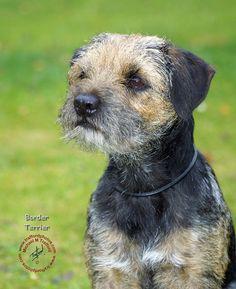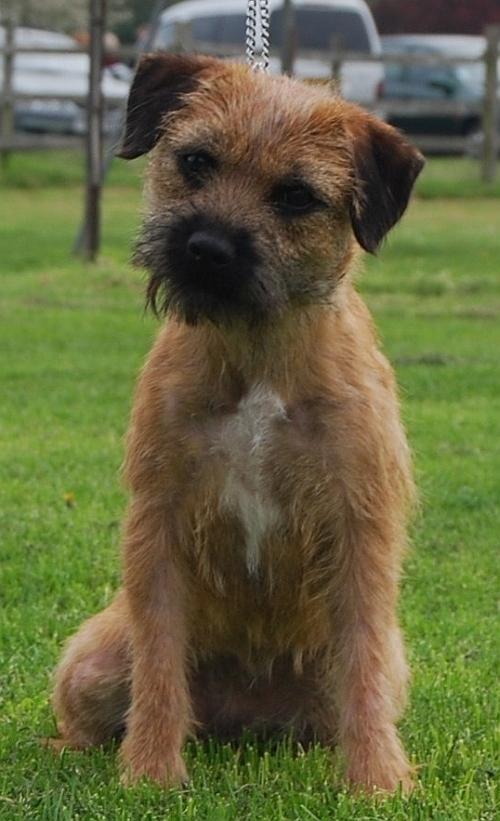The first image is the image on the left, the second image is the image on the right. For the images shown, is this caption "the dog in the image on the right is standing on all fours" true? Answer yes or no. No. The first image is the image on the left, the second image is the image on the right. Assess this claim about the two images: "There are two dogs sitting on the grass.". Correct or not? Answer yes or no. Yes. 